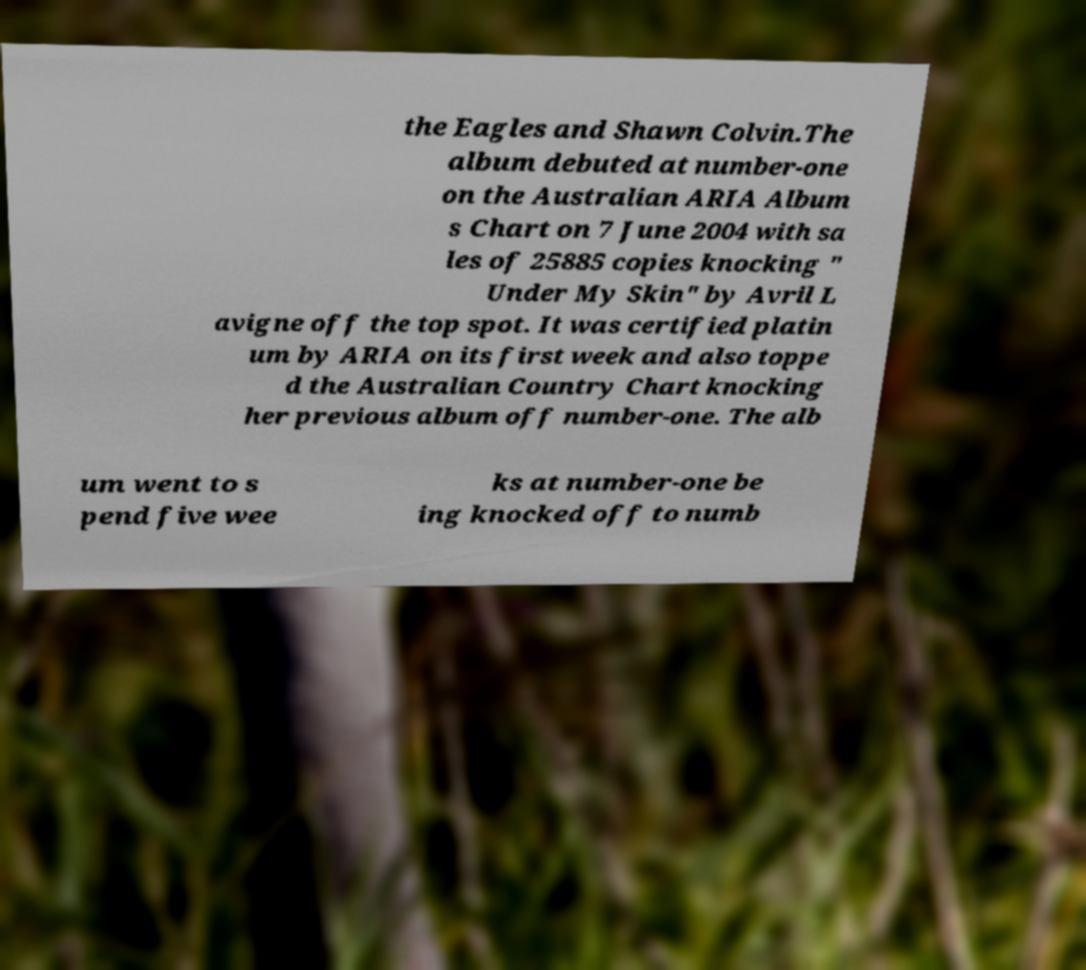Can you read and provide the text displayed in the image?This photo seems to have some interesting text. Can you extract and type it out for me? the Eagles and Shawn Colvin.The album debuted at number-one on the Australian ARIA Album s Chart on 7 June 2004 with sa les of 25885 copies knocking " Under My Skin" by Avril L avigne off the top spot. It was certified platin um by ARIA on its first week and also toppe d the Australian Country Chart knocking her previous album off number-one. The alb um went to s pend five wee ks at number-one be ing knocked off to numb 